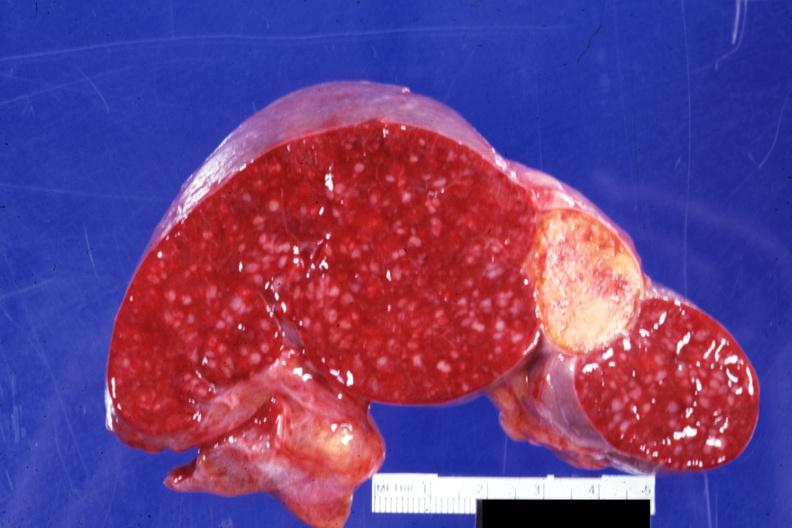what is cut surface with remote and now healed?
Answer the question using a single word or phrase. Infarct quite typical embolus for aortic valve prosthesis 